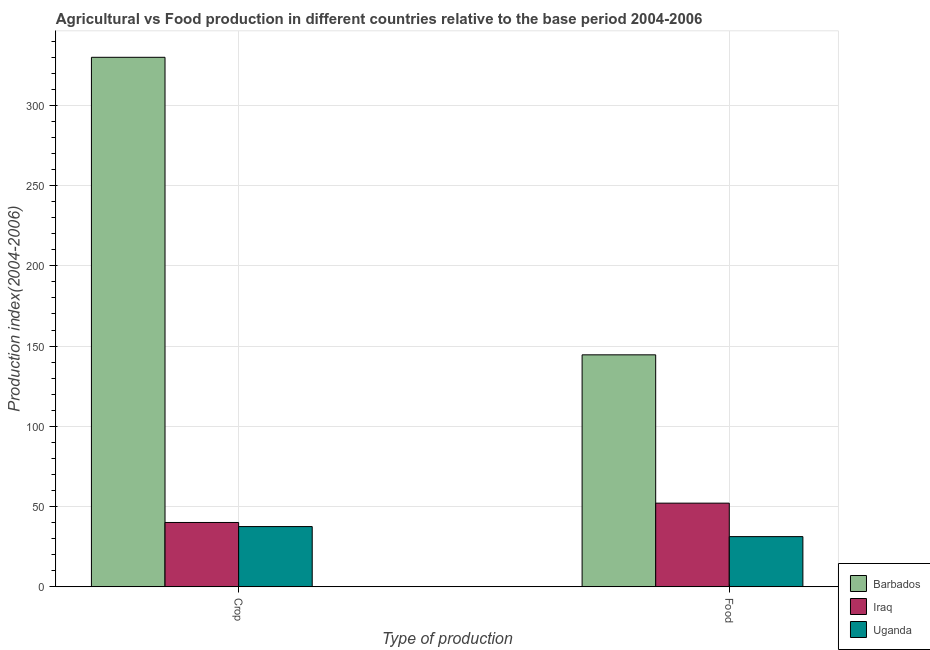How many different coloured bars are there?
Offer a terse response. 3. Are the number of bars per tick equal to the number of legend labels?
Provide a succinct answer. Yes. Are the number of bars on each tick of the X-axis equal?
Ensure brevity in your answer.  Yes. What is the label of the 1st group of bars from the left?
Ensure brevity in your answer.  Crop. What is the food production index in Uganda?
Your answer should be very brief. 31.25. Across all countries, what is the maximum crop production index?
Your answer should be very brief. 329.99. Across all countries, what is the minimum food production index?
Your response must be concise. 31.25. In which country was the crop production index maximum?
Ensure brevity in your answer.  Barbados. In which country was the food production index minimum?
Give a very brief answer. Uganda. What is the total food production index in the graph?
Your response must be concise. 227.91. What is the difference between the crop production index in Uganda and that in Iraq?
Your answer should be very brief. -2.55. What is the difference between the crop production index in Barbados and the food production index in Iraq?
Offer a terse response. 277.88. What is the average crop production index per country?
Offer a very short reply. 135.85. What is the difference between the crop production index and food production index in Iraq?
Your response must be concise. -12.05. What is the ratio of the food production index in Uganda to that in Barbados?
Make the answer very short. 0.22. In how many countries, is the crop production index greater than the average crop production index taken over all countries?
Ensure brevity in your answer.  1. What does the 2nd bar from the left in Food represents?
Your answer should be compact. Iraq. What does the 1st bar from the right in Crop represents?
Provide a short and direct response. Uganda. How many bars are there?
Offer a terse response. 6. Are all the bars in the graph horizontal?
Give a very brief answer. No. What is the difference between two consecutive major ticks on the Y-axis?
Your response must be concise. 50. Are the values on the major ticks of Y-axis written in scientific E-notation?
Provide a short and direct response. No. Where does the legend appear in the graph?
Your answer should be compact. Bottom right. How are the legend labels stacked?
Your response must be concise. Vertical. What is the title of the graph?
Provide a short and direct response. Agricultural vs Food production in different countries relative to the base period 2004-2006. Does "Austria" appear as one of the legend labels in the graph?
Ensure brevity in your answer.  No. What is the label or title of the X-axis?
Ensure brevity in your answer.  Type of production. What is the label or title of the Y-axis?
Your answer should be compact. Production index(2004-2006). What is the Production index(2004-2006) of Barbados in Crop?
Give a very brief answer. 329.99. What is the Production index(2004-2006) in Iraq in Crop?
Your response must be concise. 40.06. What is the Production index(2004-2006) in Uganda in Crop?
Your answer should be very brief. 37.51. What is the Production index(2004-2006) of Barbados in Food?
Your answer should be very brief. 144.55. What is the Production index(2004-2006) of Iraq in Food?
Provide a short and direct response. 52.11. What is the Production index(2004-2006) in Uganda in Food?
Keep it short and to the point. 31.25. Across all Type of production, what is the maximum Production index(2004-2006) in Barbados?
Your answer should be very brief. 329.99. Across all Type of production, what is the maximum Production index(2004-2006) in Iraq?
Give a very brief answer. 52.11. Across all Type of production, what is the maximum Production index(2004-2006) in Uganda?
Provide a short and direct response. 37.51. Across all Type of production, what is the minimum Production index(2004-2006) in Barbados?
Provide a succinct answer. 144.55. Across all Type of production, what is the minimum Production index(2004-2006) in Iraq?
Make the answer very short. 40.06. Across all Type of production, what is the minimum Production index(2004-2006) in Uganda?
Make the answer very short. 31.25. What is the total Production index(2004-2006) in Barbados in the graph?
Give a very brief answer. 474.54. What is the total Production index(2004-2006) of Iraq in the graph?
Make the answer very short. 92.17. What is the total Production index(2004-2006) of Uganda in the graph?
Your response must be concise. 68.76. What is the difference between the Production index(2004-2006) of Barbados in Crop and that in Food?
Your answer should be compact. 185.44. What is the difference between the Production index(2004-2006) of Iraq in Crop and that in Food?
Give a very brief answer. -12.05. What is the difference between the Production index(2004-2006) of Uganda in Crop and that in Food?
Offer a terse response. 6.26. What is the difference between the Production index(2004-2006) in Barbados in Crop and the Production index(2004-2006) in Iraq in Food?
Provide a short and direct response. 277.88. What is the difference between the Production index(2004-2006) in Barbados in Crop and the Production index(2004-2006) in Uganda in Food?
Your answer should be very brief. 298.74. What is the difference between the Production index(2004-2006) of Iraq in Crop and the Production index(2004-2006) of Uganda in Food?
Offer a very short reply. 8.81. What is the average Production index(2004-2006) in Barbados per Type of production?
Ensure brevity in your answer.  237.27. What is the average Production index(2004-2006) of Iraq per Type of production?
Ensure brevity in your answer.  46.09. What is the average Production index(2004-2006) in Uganda per Type of production?
Give a very brief answer. 34.38. What is the difference between the Production index(2004-2006) of Barbados and Production index(2004-2006) of Iraq in Crop?
Make the answer very short. 289.93. What is the difference between the Production index(2004-2006) in Barbados and Production index(2004-2006) in Uganda in Crop?
Provide a short and direct response. 292.48. What is the difference between the Production index(2004-2006) in Iraq and Production index(2004-2006) in Uganda in Crop?
Keep it short and to the point. 2.55. What is the difference between the Production index(2004-2006) in Barbados and Production index(2004-2006) in Iraq in Food?
Provide a succinct answer. 92.44. What is the difference between the Production index(2004-2006) of Barbados and Production index(2004-2006) of Uganda in Food?
Offer a very short reply. 113.3. What is the difference between the Production index(2004-2006) of Iraq and Production index(2004-2006) of Uganda in Food?
Give a very brief answer. 20.86. What is the ratio of the Production index(2004-2006) of Barbados in Crop to that in Food?
Keep it short and to the point. 2.28. What is the ratio of the Production index(2004-2006) of Iraq in Crop to that in Food?
Make the answer very short. 0.77. What is the ratio of the Production index(2004-2006) of Uganda in Crop to that in Food?
Your answer should be very brief. 1.2. What is the difference between the highest and the second highest Production index(2004-2006) of Barbados?
Keep it short and to the point. 185.44. What is the difference between the highest and the second highest Production index(2004-2006) in Iraq?
Your answer should be very brief. 12.05. What is the difference between the highest and the second highest Production index(2004-2006) of Uganda?
Your answer should be very brief. 6.26. What is the difference between the highest and the lowest Production index(2004-2006) in Barbados?
Ensure brevity in your answer.  185.44. What is the difference between the highest and the lowest Production index(2004-2006) in Iraq?
Your answer should be compact. 12.05. What is the difference between the highest and the lowest Production index(2004-2006) in Uganda?
Your answer should be compact. 6.26. 